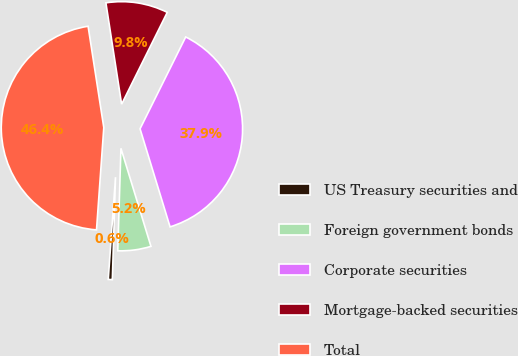<chart> <loc_0><loc_0><loc_500><loc_500><pie_chart><fcel>US Treasury securities and<fcel>Foreign government bonds<fcel>Corporate securities<fcel>Mortgage-backed securities<fcel>Total<nl><fcel>0.64%<fcel>5.22%<fcel>37.93%<fcel>9.79%<fcel>46.42%<nl></chart> 